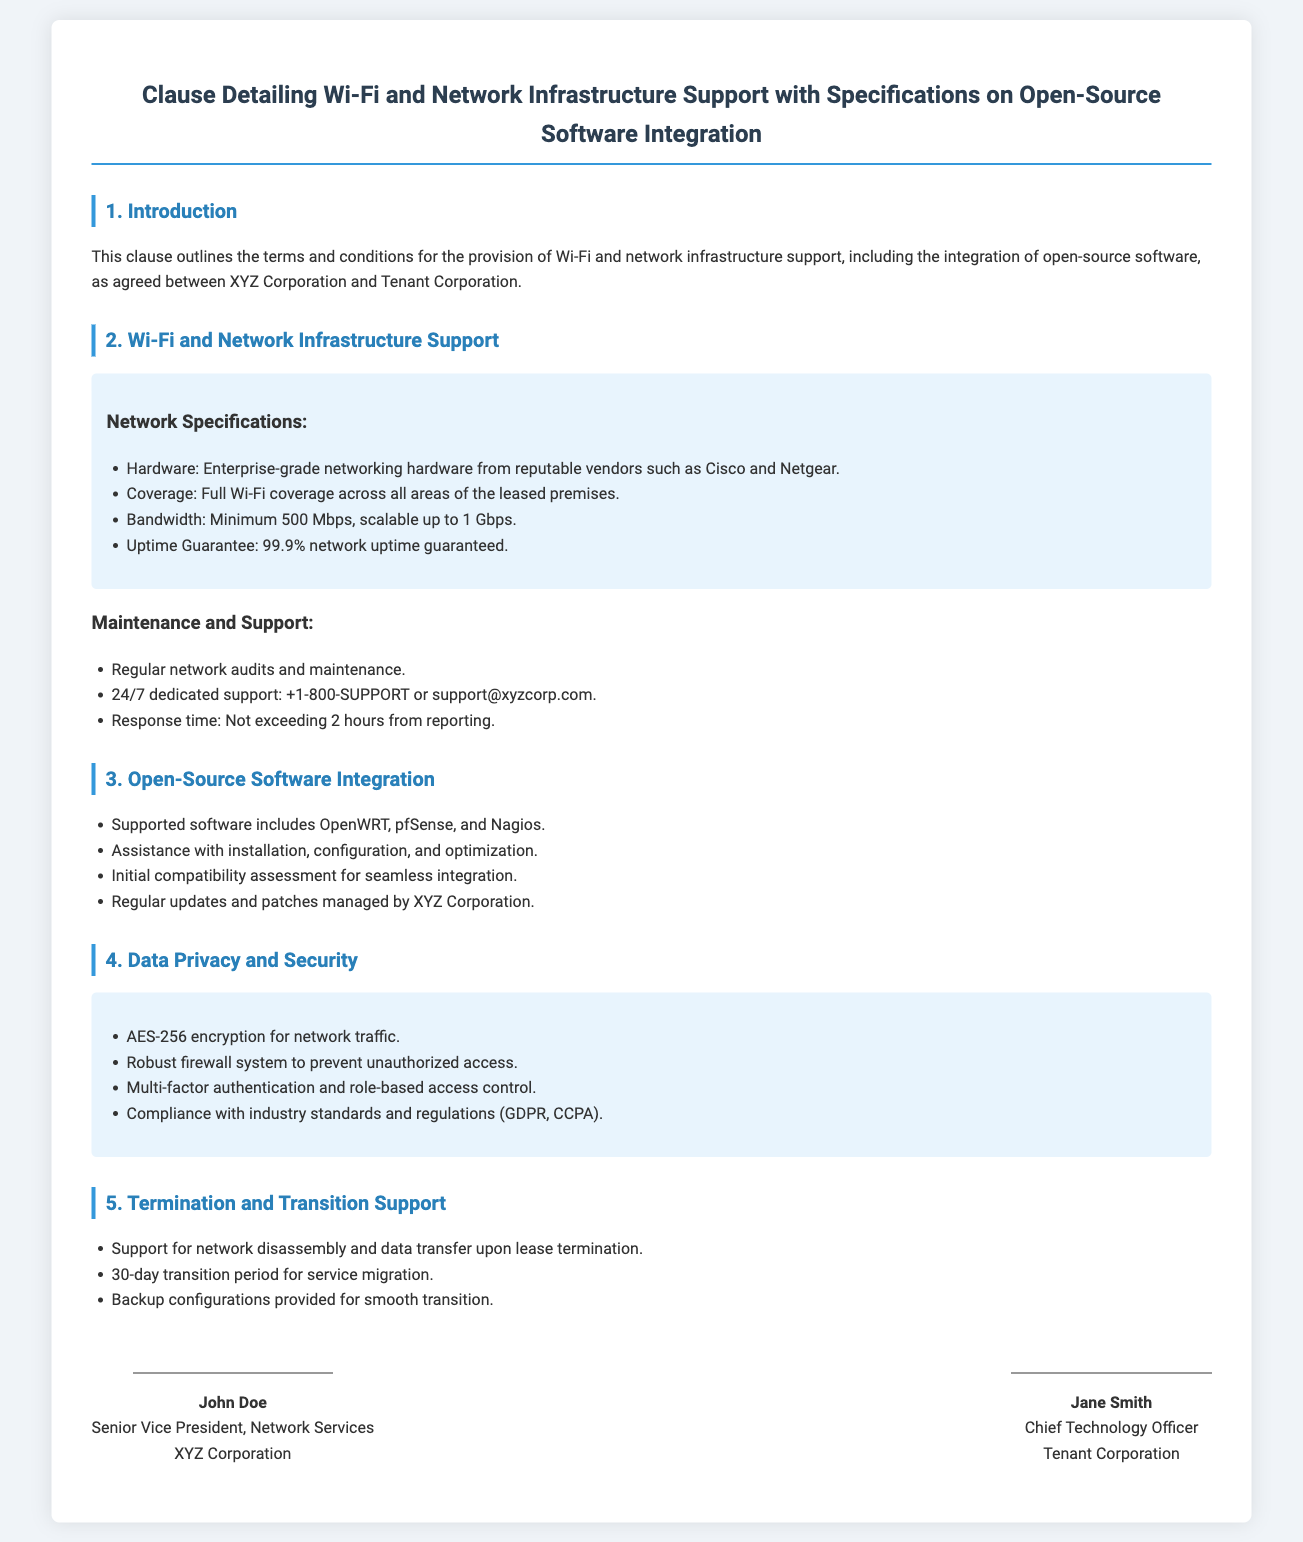What is the required bandwidth? The required bandwidth is specified in the section on Network Specifications, stating a minimum of 500 Mbps.
Answer: 500 Mbps What is the uptime guarantee? The uptime guarantee is mentioned under Network Specifications as 99.9% network uptime guaranteed.
Answer: 99.9% Which open-source software is supported? The supported software is listed under Open-Source Software Integration, including OpenWRT, pfSense, and Nagios.
Answer: OpenWRT, pfSense, and Nagios What encryption standard is used for network traffic? The encryption standard is detailed in the Data Privacy and Security section, where AES-256 encryption is specified.
Answer: AES-256 What is the response time for support requests? The response time is stated under Maintenance and Support as not exceeding 2 hours from reporting.
Answer: 2 hours What type of hardware is required? The type of hardware is listed in Network Specifications, indicating enterprise-grade networking hardware from reputable vendors.
Answer: Enterprise-grade networking hardware How long is the transition period for service migration? The transition period is mentioned in the Termination and Transition Support section as 30 days.
Answer: 30 days Who is the Senior Vice President of Network Services? The Senior Vice President of Network Services is identified at the end of the document as John Doe.
Answer: John Doe What is included in the backup configurations? Backup configurations for a smooth transition are mentioned in Termination and Transition Support, but specifics are not detailed in the document.
Answer: Backup configurations provided for smooth transition 